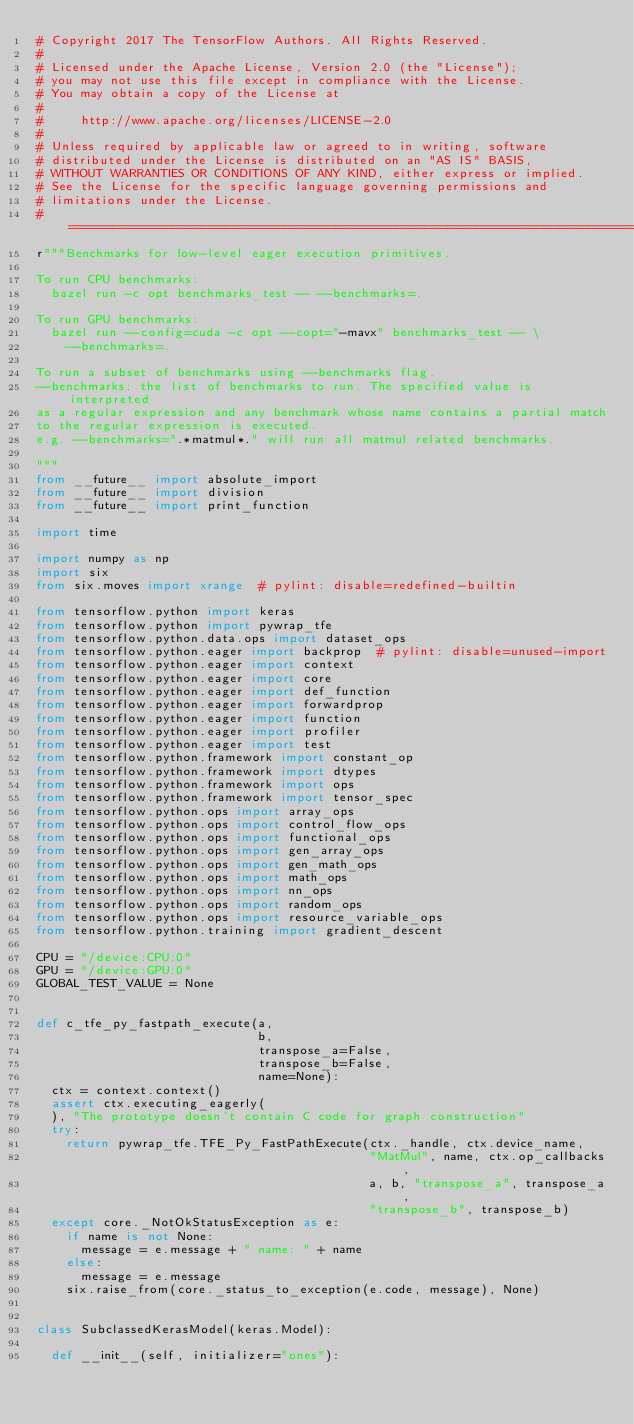Convert code to text. <code><loc_0><loc_0><loc_500><loc_500><_Python_># Copyright 2017 The TensorFlow Authors. All Rights Reserved.
#
# Licensed under the Apache License, Version 2.0 (the "License");
# you may not use this file except in compliance with the License.
# You may obtain a copy of the License at
#
#     http://www.apache.org/licenses/LICENSE-2.0
#
# Unless required by applicable law or agreed to in writing, software
# distributed under the License is distributed on an "AS IS" BASIS,
# WITHOUT WARRANTIES OR CONDITIONS OF ANY KIND, either express or implied.
# See the License for the specific language governing permissions and
# limitations under the License.
# ==============================================================================
r"""Benchmarks for low-level eager execution primitives.

To run CPU benchmarks:
  bazel run -c opt benchmarks_test -- --benchmarks=.

To run GPU benchmarks:
  bazel run --config=cuda -c opt --copt="-mavx" benchmarks_test -- \
    --benchmarks=.

To run a subset of benchmarks using --benchmarks flag.
--benchmarks: the list of benchmarks to run. The specified value is interpreted
as a regular expression and any benchmark whose name contains a partial match
to the regular expression is executed.
e.g. --benchmarks=".*matmul*." will run all matmul related benchmarks.

"""
from __future__ import absolute_import
from __future__ import division
from __future__ import print_function

import time

import numpy as np
import six
from six.moves import xrange  # pylint: disable=redefined-builtin

from tensorflow.python import keras
from tensorflow.python import pywrap_tfe
from tensorflow.python.data.ops import dataset_ops
from tensorflow.python.eager import backprop  # pylint: disable=unused-import
from tensorflow.python.eager import context
from tensorflow.python.eager import core
from tensorflow.python.eager import def_function
from tensorflow.python.eager import forwardprop
from tensorflow.python.eager import function
from tensorflow.python.eager import profiler
from tensorflow.python.eager import test
from tensorflow.python.framework import constant_op
from tensorflow.python.framework import dtypes
from tensorflow.python.framework import ops
from tensorflow.python.framework import tensor_spec
from tensorflow.python.ops import array_ops
from tensorflow.python.ops import control_flow_ops
from tensorflow.python.ops import functional_ops
from tensorflow.python.ops import gen_array_ops
from tensorflow.python.ops import gen_math_ops
from tensorflow.python.ops import math_ops
from tensorflow.python.ops import nn_ops
from tensorflow.python.ops import random_ops
from tensorflow.python.ops import resource_variable_ops
from tensorflow.python.training import gradient_descent

CPU = "/device:CPU:0"
GPU = "/device:GPU:0"
GLOBAL_TEST_VALUE = None


def c_tfe_py_fastpath_execute(a,
                              b,
                              transpose_a=False,
                              transpose_b=False,
                              name=None):
  ctx = context.context()
  assert ctx.executing_eagerly(
  ), "The prototype doesn't contain C code for graph construction"
  try:
    return pywrap_tfe.TFE_Py_FastPathExecute(ctx._handle, ctx.device_name,
                                             "MatMul", name, ctx.op_callbacks,
                                             a, b, "transpose_a", transpose_a,
                                             "transpose_b", transpose_b)
  except core._NotOkStatusException as e:
    if name is not None:
      message = e.message + " name: " + name
    else:
      message = e.message
    six.raise_from(core._status_to_exception(e.code, message), None)


class SubclassedKerasModel(keras.Model):

  def __init__(self, initializer="ones"):</code> 